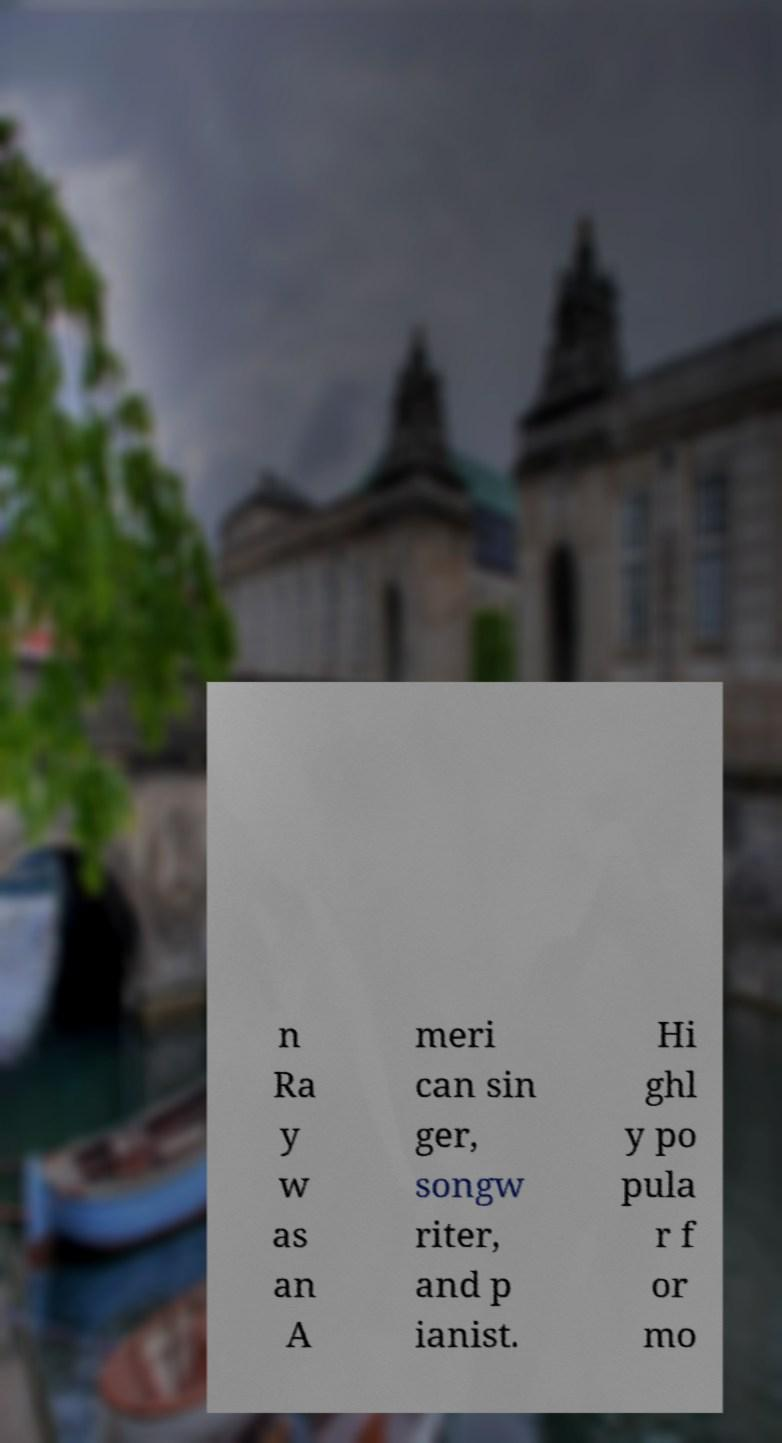Please read and relay the text visible in this image. What does it say? n Ra y w as an A meri can sin ger, songw riter, and p ianist. Hi ghl y po pula r f or mo 